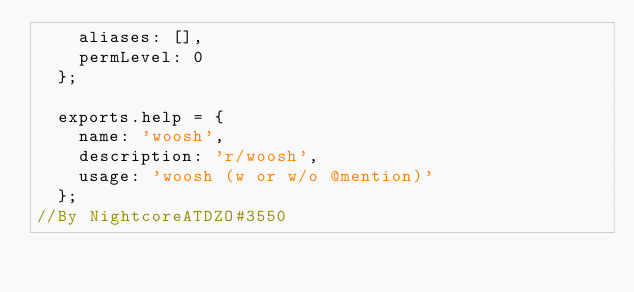Convert code to text. <code><loc_0><loc_0><loc_500><loc_500><_JavaScript_>    aliases: [],
    permLevel: 0
  };
  
  exports.help = {
    name: 'woosh',
    description: 'r/woosh',
    usage: 'woosh (w or w/o @mention)'
  };
//By NightcoreATDZO#3550
</code> 